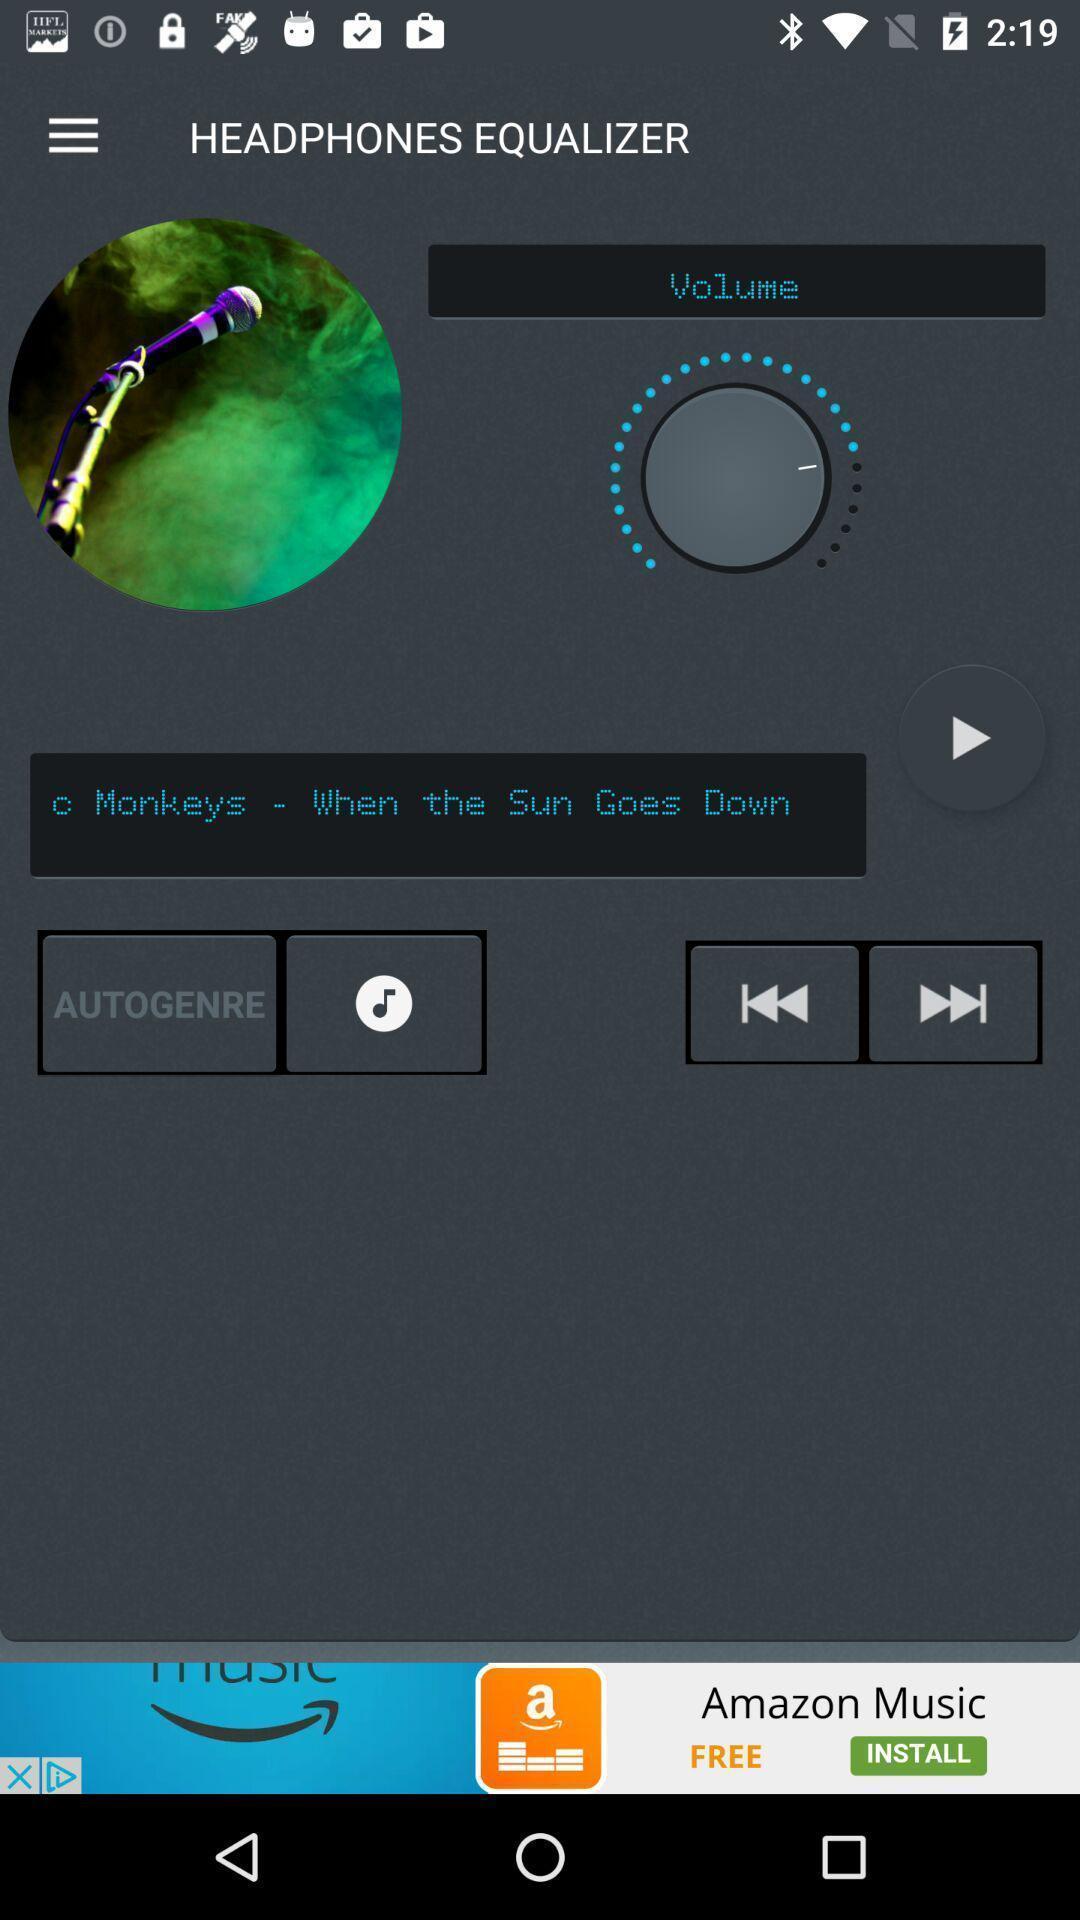Give me a summary of this screen capture. Page displaying various sound options. 